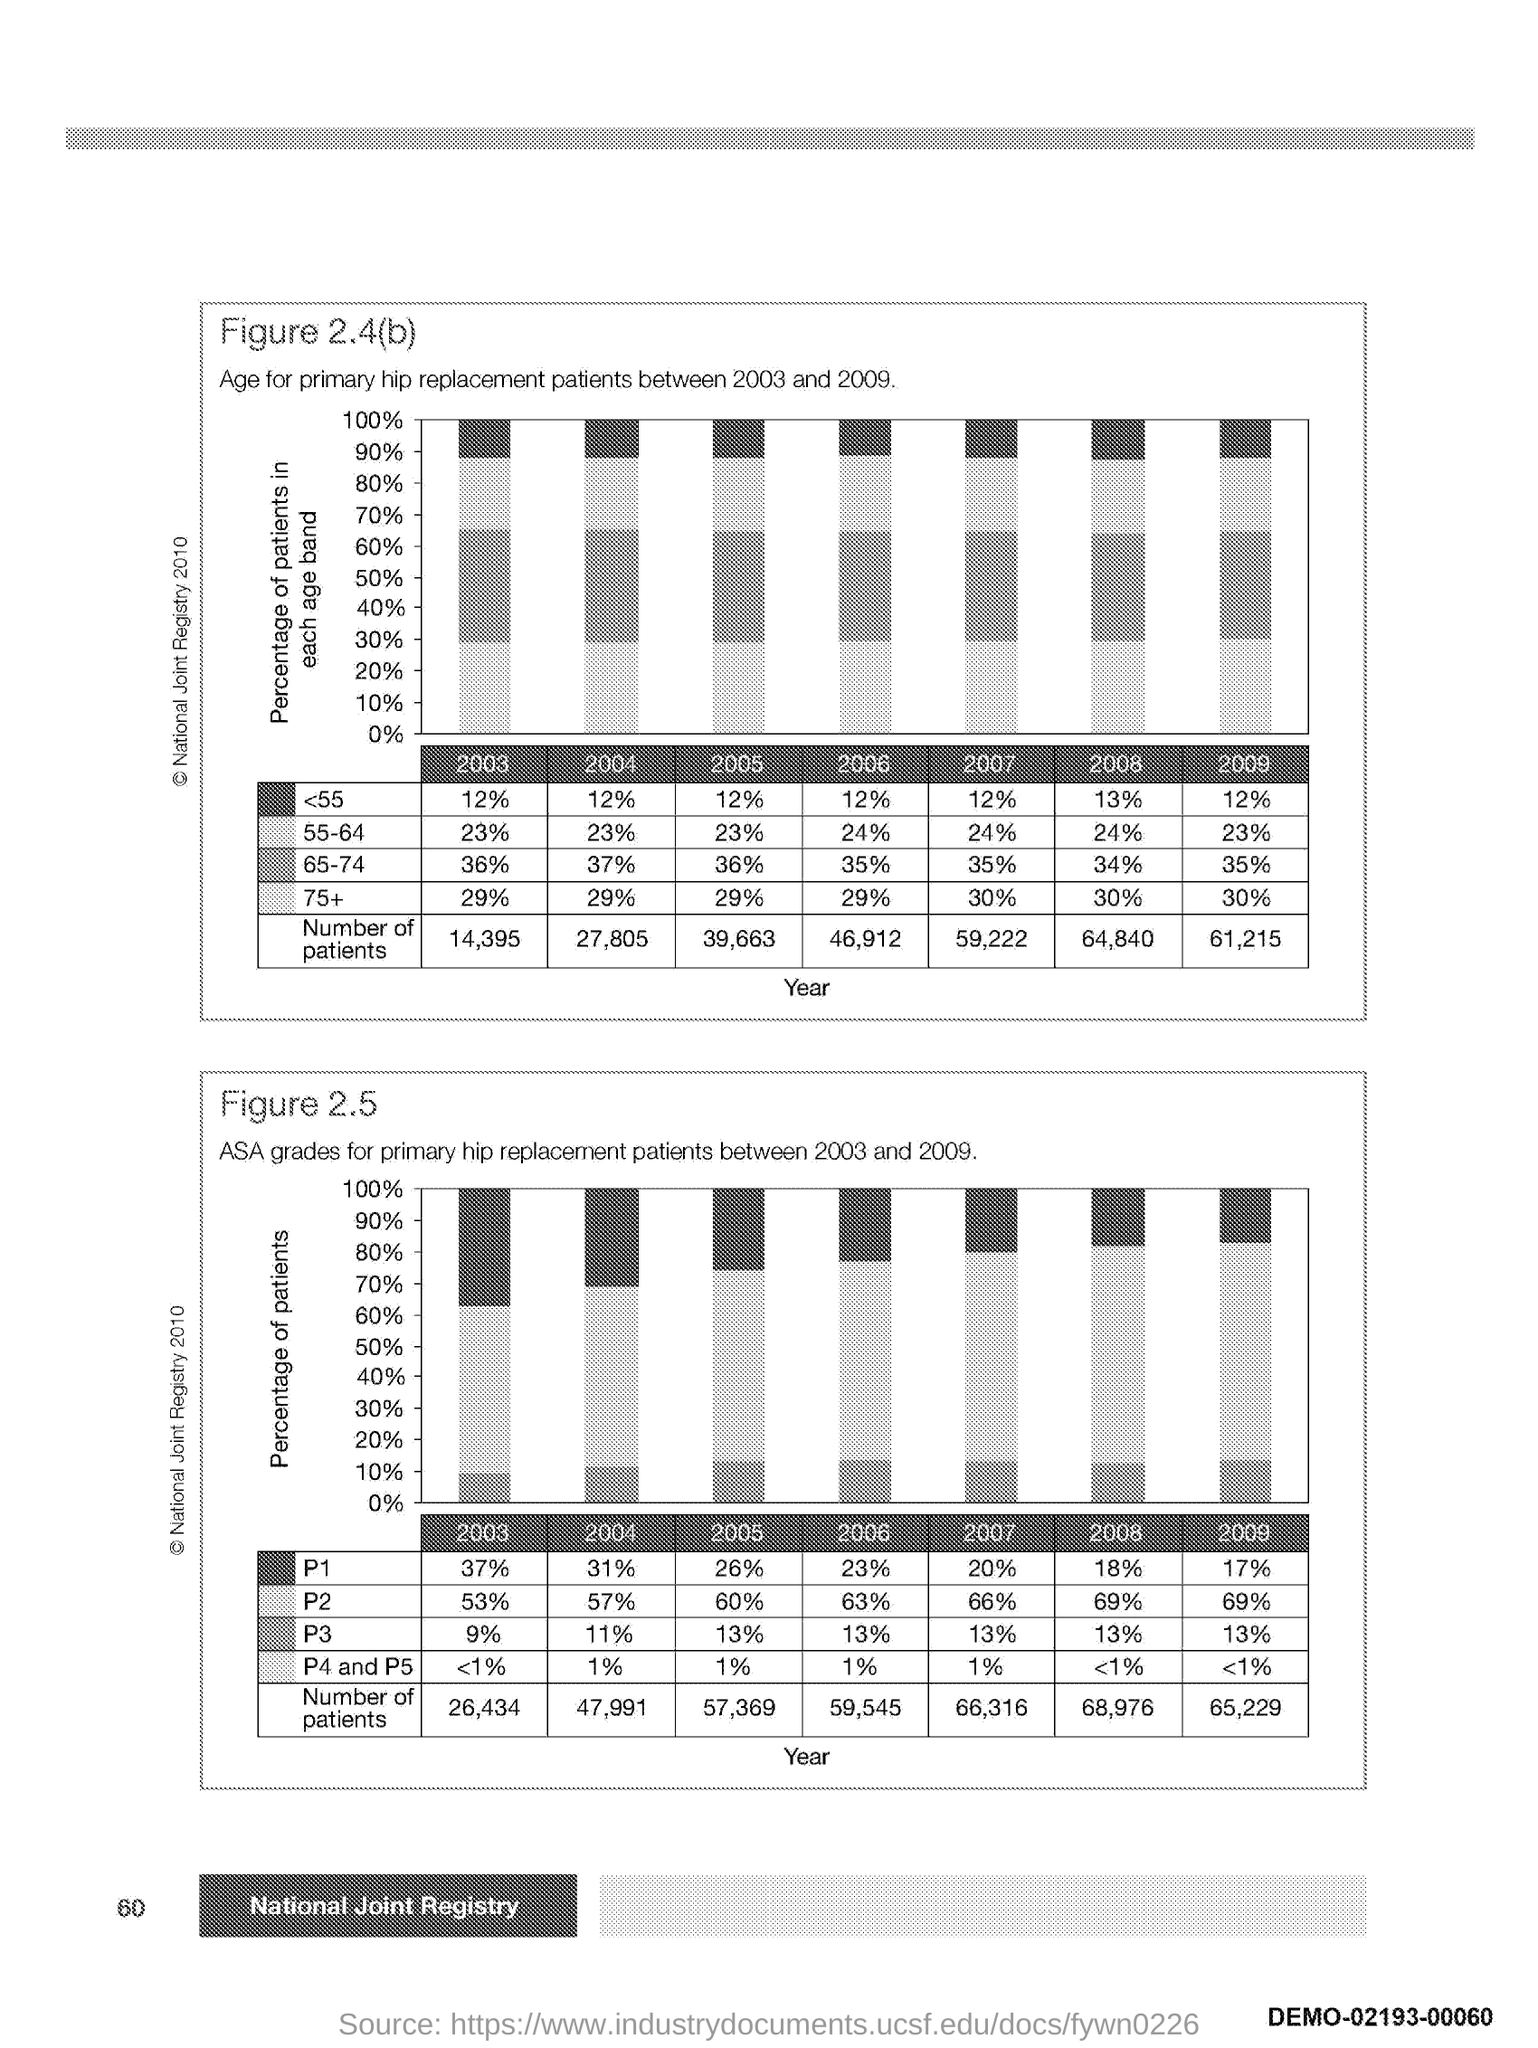What is plotted in the y-axis of second graph?
Your answer should be very brief. Percentage of Patients. What is plotted in the x-axis of first graph?
Offer a terse response. Year. 